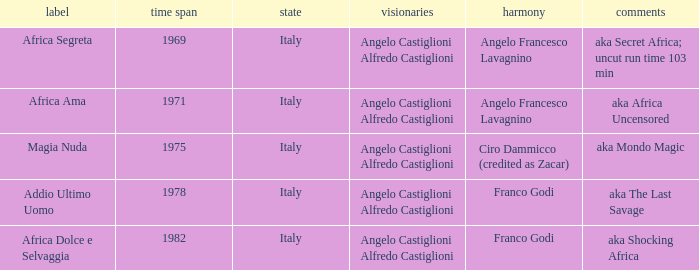What is the country that has a music writer of Angelo Francesco Lavagnino, written in 1969? Italy. 